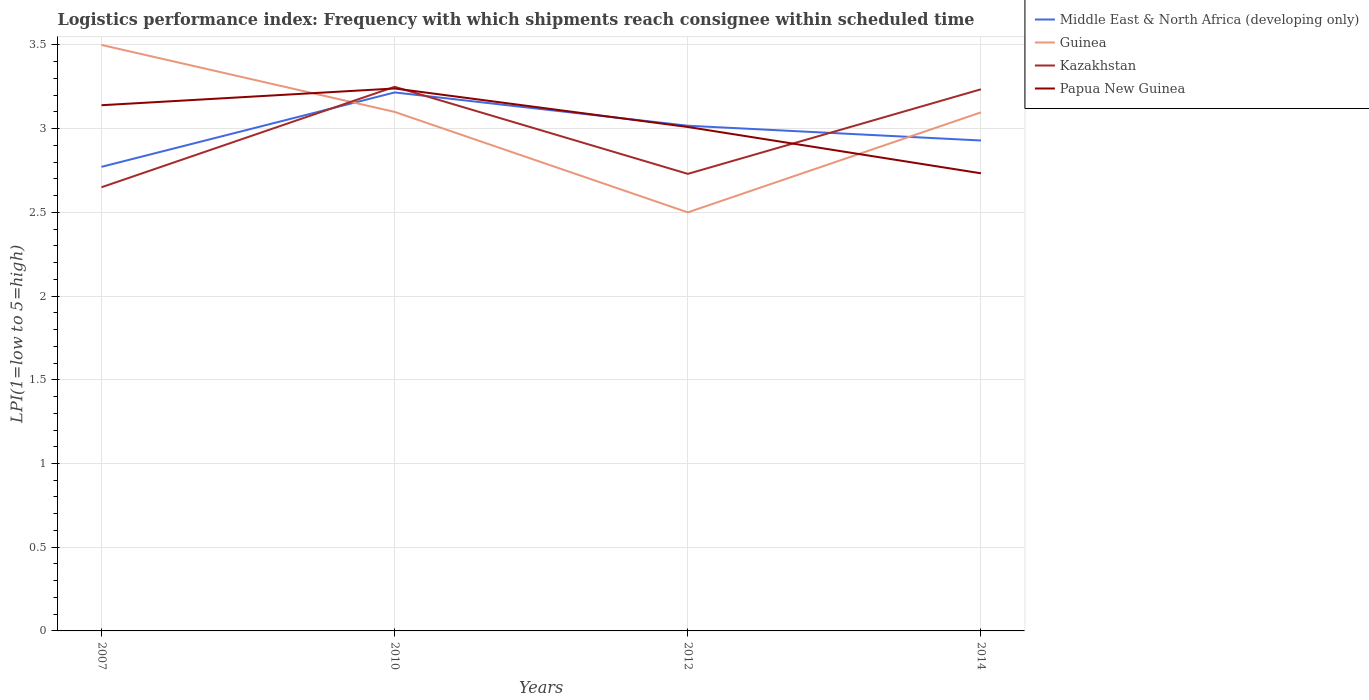How many different coloured lines are there?
Keep it short and to the point. 4. Across all years, what is the maximum logistics performance index in Papua New Guinea?
Your response must be concise. 2.73. In which year was the logistics performance index in Middle East & North Africa (developing only) maximum?
Your answer should be very brief. 2007. What is the total logistics performance index in Kazakhstan in the graph?
Provide a succinct answer. 0.52. What is the difference between the highest and the second highest logistics performance index in Papua New Guinea?
Ensure brevity in your answer.  0.51. What is the difference between the highest and the lowest logistics performance index in Middle East & North Africa (developing only)?
Give a very brief answer. 2. Is the logistics performance index in Middle East & North Africa (developing only) strictly greater than the logistics performance index in Papua New Guinea over the years?
Your answer should be very brief. No. How many years are there in the graph?
Ensure brevity in your answer.  4. What is the difference between two consecutive major ticks on the Y-axis?
Offer a terse response. 0.5. Where does the legend appear in the graph?
Your response must be concise. Top right. How are the legend labels stacked?
Your answer should be compact. Vertical. What is the title of the graph?
Make the answer very short. Logistics performance index: Frequency with which shipments reach consignee within scheduled time. What is the label or title of the X-axis?
Give a very brief answer. Years. What is the label or title of the Y-axis?
Offer a very short reply. LPI(1=low to 5=high). What is the LPI(1=low to 5=high) of Middle East & North Africa (developing only) in 2007?
Your answer should be compact. 2.77. What is the LPI(1=low to 5=high) of Guinea in 2007?
Keep it short and to the point. 3.5. What is the LPI(1=low to 5=high) of Kazakhstan in 2007?
Your answer should be very brief. 2.65. What is the LPI(1=low to 5=high) of Papua New Guinea in 2007?
Provide a succinct answer. 3.14. What is the LPI(1=low to 5=high) in Middle East & North Africa (developing only) in 2010?
Your answer should be compact. 3.22. What is the LPI(1=low to 5=high) in Guinea in 2010?
Give a very brief answer. 3.1. What is the LPI(1=low to 5=high) in Kazakhstan in 2010?
Your response must be concise. 3.25. What is the LPI(1=low to 5=high) of Papua New Guinea in 2010?
Your answer should be very brief. 3.24. What is the LPI(1=low to 5=high) of Middle East & North Africa (developing only) in 2012?
Offer a very short reply. 3.02. What is the LPI(1=low to 5=high) of Guinea in 2012?
Provide a short and direct response. 2.5. What is the LPI(1=low to 5=high) of Kazakhstan in 2012?
Your answer should be very brief. 2.73. What is the LPI(1=low to 5=high) in Papua New Guinea in 2012?
Your response must be concise. 3.01. What is the LPI(1=low to 5=high) in Middle East & North Africa (developing only) in 2014?
Make the answer very short. 2.93. What is the LPI(1=low to 5=high) in Guinea in 2014?
Ensure brevity in your answer.  3.1. What is the LPI(1=low to 5=high) in Kazakhstan in 2014?
Your response must be concise. 3.24. What is the LPI(1=low to 5=high) in Papua New Guinea in 2014?
Offer a terse response. 2.73. Across all years, what is the maximum LPI(1=low to 5=high) in Middle East & North Africa (developing only)?
Provide a short and direct response. 3.22. Across all years, what is the maximum LPI(1=low to 5=high) in Kazakhstan?
Your answer should be compact. 3.25. Across all years, what is the maximum LPI(1=low to 5=high) in Papua New Guinea?
Your answer should be compact. 3.24. Across all years, what is the minimum LPI(1=low to 5=high) in Middle East & North Africa (developing only)?
Your response must be concise. 2.77. Across all years, what is the minimum LPI(1=low to 5=high) in Kazakhstan?
Provide a short and direct response. 2.65. Across all years, what is the minimum LPI(1=low to 5=high) of Papua New Guinea?
Ensure brevity in your answer.  2.73. What is the total LPI(1=low to 5=high) of Middle East & North Africa (developing only) in the graph?
Ensure brevity in your answer.  11.94. What is the total LPI(1=low to 5=high) in Guinea in the graph?
Your answer should be compact. 12.2. What is the total LPI(1=low to 5=high) of Kazakhstan in the graph?
Your response must be concise. 11.87. What is the total LPI(1=low to 5=high) in Papua New Guinea in the graph?
Offer a very short reply. 12.12. What is the difference between the LPI(1=low to 5=high) of Middle East & North Africa (developing only) in 2007 and that in 2010?
Keep it short and to the point. -0.44. What is the difference between the LPI(1=low to 5=high) of Middle East & North Africa (developing only) in 2007 and that in 2012?
Your answer should be very brief. -0.25. What is the difference between the LPI(1=low to 5=high) of Guinea in 2007 and that in 2012?
Offer a terse response. 1. What is the difference between the LPI(1=low to 5=high) in Kazakhstan in 2007 and that in 2012?
Your answer should be compact. -0.08. What is the difference between the LPI(1=low to 5=high) of Papua New Guinea in 2007 and that in 2012?
Offer a very short reply. 0.13. What is the difference between the LPI(1=low to 5=high) of Middle East & North Africa (developing only) in 2007 and that in 2014?
Your answer should be compact. -0.16. What is the difference between the LPI(1=low to 5=high) of Guinea in 2007 and that in 2014?
Your answer should be very brief. 0.4. What is the difference between the LPI(1=low to 5=high) in Kazakhstan in 2007 and that in 2014?
Offer a terse response. -0.59. What is the difference between the LPI(1=low to 5=high) of Papua New Guinea in 2007 and that in 2014?
Offer a terse response. 0.41. What is the difference between the LPI(1=low to 5=high) of Middle East & North Africa (developing only) in 2010 and that in 2012?
Offer a very short reply. 0.2. What is the difference between the LPI(1=low to 5=high) in Guinea in 2010 and that in 2012?
Keep it short and to the point. 0.6. What is the difference between the LPI(1=low to 5=high) in Kazakhstan in 2010 and that in 2012?
Your answer should be compact. 0.52. What is the difference between the LPI(1=low to 5=high) in Papua New Guinea in 2010 and that in 2012?
Make the answer very short. 0.23. What is the difference between the LPI(1=low to 5=high) of Middle East & North Africa (developing only) in 2010 and that in 2014?
Ensure brevity in your answer.  0.29. What is the difference between the LPI(1=low to 5=high) of Guinea in 2010 and that in 2014?
Give a very brief answer. 0. What is the difference between the LPI(1=low to 5=high) of Kazakhstan in 2010 and that in 2014?
Your response must be concise. 0.01. What is the difference between the LPI(1=low to 5=high) in Papua New Guinea in 2010 and that in 2014?
Your answer should be compact. 0.51. What is the difference between the LPI(1=low to 5=high) in Middle East & North Africa (developing only) in 2012 and that in 2014?
Your answer should be very brief. 0.09. What is the difference between the LPI(1=low to 5=high) of Guinea in 2012 and that in 2014?
Offer a terse response. -0.6. What is the difference between the LPI(1=low to 5=high) of Kazakhstan in 2012 and that in 2014?
Keep it short and to the point. -0.51. What is the difference between the LPI(1=low to 5=high) in Papua New Guinea in 2012 and that in 2014?
Make the answer very short. 0.28. What is the difference between the LPI(1=low to 5=high) of Middle East & North Africa (developing only) in 2007 and the LPI(1=low to 5=high) of Guinea in 2010?
Provide a short and direct response. -0.33. What is the difference between the LPI(1=low to 5=high) in Middle East & North Africa (developing only) in 2007 and the LPI(1=low to 5=high) in Kazakhstan in 2010?
Offer a terse response. -0.48. What is the difference between the LPI(1=low to 5=high) of Middle East & North Africa (developing only) in 2007 and the LPI(1=low to 5=high) of Papua New Guinea in 2010?
Keep it short and to the point. -0.47. What is the difference between the LPI(1=low to 5=high) in Guinea in 2007 and the LPI(1=low to 5=high) in Kazakhstan in 2010?
Provide a succinct answer. 0.25. What is the difference between the LPI(1=low to 5=high) in Guinea in 2007 and the LPI(1=low to 5=high) in Papua New Guinea in 2010?
Ensure brevity in your answer.  0.26. What is the difference between the LPI(1=low to 5=high) in Kazakhstan in 2007 and the LPI(1=low to 5=high) in Papua New Guinea in 2010?
Offer a very short reply. -0.59. What is the difference between the LPI(1=low to 5=high) in Middle East & North Africa (developing only) in 2007 and the LPI(1=low to 5=high) in Guinea in 2012?
Keep it short and to the point. 0.27. What is the difference between the LPI(1=low to 5=high) of Middle East & North Africa (developing only) in 2007 and the LPI(1=low to 5=high) of Kazakhstan in 2012?
Provide a short and direct response. 0.04. What is the difference between the LPI(1=low to 5=high) of Middle East & North Africa (developing only) in 2007 and the LPI(1=low to 5=high) of Papua New Guinea in 2012?
Provide a short and direct response. -0.24. What is the difference between the LPI(1=low to 5=high) in Guinea in 2007 and the LPI(1=low to 5=high) in Kazakhstan in 2012?
Provide a succinct answer. 0.77. What is the difference between the LPI(1=low to 5=high) of Guinea in 2007 and the LPI(1=low to 5=high) of Papua New Guinea in 2012?
Make the answer very short. 0.49. What is the difference between the LPI(1=low to 5=high) in Kazakhstan in 2007 and the LPI(1=low to 5=high) in Papua New Guinea in 2012?
Keep it short and to the point. -0.36. What is the difference between the LPI(1=low to 5=high) of Middle East & North Africa (developing only) in 2007 and the LPI(1=low to 5=high) of Guinea in 2014?
Your answer should be very brief. -0.33. What is the difference between the LPI(1=low to 5=high) of Middle East & North Africa (developing only) in 2007 and the LPI(1=low to 5=high) of Kazakhstan in 2014?
Your answer should be very brief. -0.46. What is the difference between the LPI(1=low to 5=high) of Middle East & North Africa (developing only) in 2007 and the LPI(1=low to 5=high) of Papua New Guinea in 2014?
Provide a succinct answer. 0.04. What is the difference between the LPI(1=low to 5=high) of Guinea in 2007 and the LPI(1=low to 5=high) of Kazakhstan in 2014?
Make the answer very short. 0.26. What is the difference between the LPI(1=low to 5=high) in Guinea in 2007 and the LPI(1=low to 5=high) in Papua New Guinea in 2014?
Give a very brief answer. 0.77. What is the difference between the LPI(1=low to 5=high) in Kazakhstan in 2007 and the LPI(1=low to 5=high) in Papua New Guinea in 2014?
Your response must be concise. -0.08. What is the difference between the LPI(1=low to 5=high) in Middle East & North Africa (developing only) in 2010 and the LPI(1=low to 5=high) in Guinea in 2012?
Your response must be concise. 0.72. What is the difference between the LPI(1=low to 5=high) of Middle East & North Africa (developing only) in 2010 and the LPI(1=low to 5=high) of Kazakhstan in 2012?
Give a very brief answer. 0.49. What is the difference between the LPI(1=low to 5=high) in Middle East & North Africa (developing only) in 2010 and the LPI(1=low to 5=high) in Papua New Guinea in 2012?
Your response must be concise. 0.21. What is the difference between the LPI(1=low to 5=high) of Guinea in 2010 and the LPI(1=low to 5=high) of Kazakhstan in 2012?
Give a very brief answer. 0.37. What is the difference between the LPI(1=low to 5=high) in Guinea in 2010 and the LPI(1=low to 5=high) in Papua New Guinea in 2012?
Your response must be concise. 0.09. What is the difference between the LPI(1=low to 5=high) in Kazakhstan in 2010 and the LPI(1=low to 5=high) in Papua New Guinea in 2012?
Your response must be concise. 0.24. What is the difference between the LPI(1=low to 5=high) of Middle East & North Africa (developing only) in 2010 and the LPI(1=low to 5=high) of Guinea in 2014?
Your answer should be compact. 0.12. What is the difference between the LPI(1=low to 5=high) of Middle East & North Africa (developing only) in 2010 and the LPI(1=low to 5=high) of Kazakhstan in 2014?
Offer a terse response. -0.02. What is the difference between the LPI(1=low to 5=high) in Middle East & North Africa (developing only) in 2010 and the LPI(1=low to 5=high) in Papua New Guinea in 2014?
Your answer should be very brief. 0.48. What is the difference between the LPI(1=low to 5=high) in Guinea in 2010 and the LPI(1=low to 5=high) in Kazakhstan in 2014?
Offer a terse response. -0.14. What is the difference between the LPI(1=low to 5=high) in Guinea in 2010 and the LPI(1=low to 5=high) in Papua New Guinea in 2014?
Make the answer very short. 0.37. What is the difference between the LPI(1=low to 5=high) in Kazakhstan in 2010 and the LPI(1=low to 5=high) in Papua New Guinea in 2014?
Ensure brevity in your answer.  0.52. What is the difference between the LPI(1=low to 5=high) of Middle East & North Africa (developing only) in 2012 and the LPI(1=low to 5=high) of Guinea in 2014?
Keep it short and to the point. -0.08. What is the difference between the LPI(1=low to 5=high) of Middle East & North Africa (developing only) in 2012 and the LPI(1=low to 5=high) of Kazakhstan in 2014?
Make the answer very short. -0.22. What is the difference between the LPI(1=low to 5=high) of Middle East & North Africa (developing only) in 2012 and the LPI(1=low to 5=high) of Papua New Guinea in 2014?
Provide a succinct answer. 0.28. What is the difference between the LPI(1=low to 5=high) of Guinea in 2012 and the LPI(1=low to 5=high) of Kazakhstan in 2014?
Provide a short and direct response. -0.74. What is the difference between the LPI(1=low to 5=high) in Guinea in 2012 and the LPI(1=low to 5=high) in Papua New Guinea in 2014?
Provide a succinct answer. -0.23. What is the difference between the LPI(1=low to 5=high) in Kazakhstan in 2012 and the LPI(1=low to 5=high) in Papua New Guinea in 2014?
Provide a succinct answer. -0. What is the average LPI(1=low to 5=high) in Middle East & North Africa (developing only) per year?
Keep it short and to the point. 2.98. What is the average LPI(1=low to 5=high) in Guinea per year?
Your answer should be very brief. 3.05. What is the average LPI(1=low to 5=high) in Kazakhstan per year?
Provide a short and direct response. 2.97. What is the average LPI(1=low to 5=high) of Papua New Guinea per year?
Your answer should be very brief. 3.03. In the year 2007, what is the difference between the LPI(1=low to 5=high) of Middle East & North Africa (developing only) and LPI(1=low to 5=high) of Guinea?
Keep it short and to the point. -0.73. In the year 2007, what is the difference between the LPI(1=low to 5=high) in Middle East & North Africa (developing only) and LPI(1=low to 5=high) in Kazakhstan?
Provide a short and direct response. 0.12. In the year 2007, what is the difference between the LPI(1=low to 5=high) of Middle East & North Africa (developing only) and LPI(1=low to 5=high) of Papua New Guinea?
Offer a very short reply. -0.37. In the year 2007, what is the difference between the LPI(1=low to 5=high) of Guinea and LPI(1=low to 5=high) of Papua New Guinea?
Make the answer very short. 0.36. In the year 2007, what is the difference between the LPI(1=low to 5=high) in Kazakhstan and LPI(1=low to 5=high) in Papua New Guinea?
Give a very brief answer. -0.49. In the year 2010, what is the difference between the LPI(1=low to 5=high) in Middle East & North Africa (developing only) and LPI(1=low to 5=high) in Guinea?
Make the answer very short. 0.12. In the year 2010, what is the difference between the LPI(1=low to 5=high) in Middle East & North Africa (developing only) and LPI(1=low to 5=high) in Kazakhstan?
Your answer should be compact. -0.03. In the year 2010, what is the difference between the LPI(1=low to 5=high) in Middle East & North Africa (developing only) and LPI(1=low to 5=high) in Papua New Guinea?
Give a very brief answer. -0.02. In the year 2010, what is the difference between the LPI(1=low to 5=high) of Guinea and LPI(1=low to 5=high) of Papua New Guinea?
Give a very brief answer. -0.14. In the year 2010, what is the difference between the LPI(1=low to 5=high) of Kazakhstan and LPI(1=low to 5=high) of Papua New Guinea?
Make the answer very short. 0.01. In the year 2012, what is the difference between the LPI(1=low to 5=high) in Middle East & North Africa (developing only) and LPI(1=low to 5=high) in Guinea?
Your answer should be very brief. 0.52. In the year 2012, what is the difference between the LPI(1=low to 5=high) of Middle East & North Africa (developing only) and LPI(1=low to 5=high) of Kazakhstan?
Provide a short and direct response. 0.29. In the year 2012, what is the difference between the LPI(1=low to 5=high) in Middle East & North Africa (developing only) and LPI(1=low to 5=high) in Papua New Guinea?
Offer a terse response. 0.01. In the year 2012, what is the difference between the LPI(1=low to 5=high) of Guinea and LPI(1=low to 5=high) of Kazakhstan?
Offer a very short reply. -0.23. In the year 2012, what is the difference between the LPI(1=low to 5=high) of Guinea and LPI(1=low to 5=high) of Papua New Guinea?
Ensure brevity in your answer.  -0.51. In the year 2012, what is the difference between the LPI(1=low to 5=high) in Kazakhstan and LPI(1=low to 5=high) in Papua New Guinea?
Offer a very short reply. -0.28. In the year 2014, what is the difference between the LPI(1=low to 5=high) of Middle East & North Africa (developing only) and LPI(1=low to 5=high) of Guinea?
Make the answer very short. -0.17. In the year 2014, what is the difference between the LPI(1=low to 5=high) of Middle East & North Africa (developing only) and LPI(1=low to 5=high) of Kazakhstan?
Provide a succinct answer. -0.31. In the year 2014, what is the difference between the LPI(1=low to 5=high) of Middle East & North Africa (developing only) and LPI(1=low to 5=high) of Papua New Guinea?
Your answer should be very brief. 0.2. In the year 2014, what is the difference between the LPI(1=low to 5=high) of Guinea and LPI(1=low to 5=high) of Kazakhstan?
Offer a very short reply. -0.14. In the year 2014, what is the difference between the LPI(1=low to 5=high) of Guinea and LPI(1=low to 5=high) of Papua New Guinea?
Your response must be concise. 0.36. In the year 2014, what is the difference between the LPI(1=low to 5=high) in Kazakhstan and LPI(1=low to 5=high) in Papua New Guinea?
Make the answer very short. 0.5. What is the ratio of the LPI(1=low to 5=high) of Middle East & North Africa (developing only) in 2007 to that in 2010?
Ensure brevity in your answer.  0.86. What is the ratio of the LPI(1=low to 5=high) of Guinea in 2007 to that in 2010?
Give a very brief answer. 1.13. What is the ratio of the LPI(1=low to 5=high) in Kazakhstan in 2007 to that in 2010?
Your answer should be compact. 0.82. What is the ratio of the LPI(1=low to 5=high) in Papua New Guinea in 2007 to that in 2010?
Give a very brief answer. 0.97. What is the ratio of the LPI(1=low to 5=high) in Middle East & North Africa (developing only) in 2007 to that in 2012?
Ensure brevity in your answer.  0.92. What is the ratio of the LPI(1=low to 5=high) in Guinea in 2007 to that in 2012?
Give a very brief answer. 1.4. What is the ratio of the LPI(1=low to 5=high) in Kazakhstan in 2007 to that in 2012?
Provide a succinct answer. 0.97. What is the ratio of the LPI(1=low to 5=high) of Papua New Guinea in 2007 to that in 2012?
Ensure brevity in your answer.  1.04. What is the ratio of the LPI(1=low to 5=high) in Middle East & North Africa (developing only) in 2007 to that in 2014?
Offer a very short reply. 0.95. What is the ratio of the LPI(1=low to 5=high) in Guinea in 2007 to that in 2014?
Provide a succinct answer. 1.13. What is the ratio of the LPI(1=low to 5=high) of Kazakhstan in 2007 to that in 2014?
Offer a very short reply. 0.82. What is the ratio of the LPI(1=low to 5=high) of Papua New Guinea in 2007 to that in 2014?
Your response must be concise. 1.15. What is the ratio of the LPI(1=low to 5=high) of Middle East & North Africa (developing only) in 2010 to that in 2012?
Provide a short and direct response. 1.07. What is the ratio of the LPI(1=low to 5=high) of Guinea in 2010 to that in 2012?
Make the answer very short. 1.24. What is the ratio of the LPI(1=low to 5=high) of Kazakhstan in 2010 to that in 2012?
Provide a short and direct response. 1.19. What is the ratio of the LPI(1=low to 5=high) of Papua New Guinea in 2010 to that in 2012?
Provide a succinct answer. 1.08. What is the ratio of the LPI(1=low to 5=high) in Middle East & North Africa (developing only) in 2010 to that in 2014?
Keep it short and to the point. 1.1. What is the ratio of the LPI(1=low to 5=high) in Guinea in 2010 to that in 2014?
Your answer should be compact. 1. What is the ratio of the LPI(1=low to 5=high) in Papua New Guinea in 2010 to that in 2014?
Offer a very short reply. 1.19. What is the ratio of the LPI(1=low to 5=high) in Middle East & North Africa (developing only) in 2012 to that in 2014?
Give a very brief answer. 1.03. What is the ratio of the LPI(1=low to 5=high) of Guinea in 2012 to that in 2014?
Ensure brevity in your answer.  0.81. What is the ratio of the LPI(1=low to 5=high) of Kazakhstan in 2012 to that in 2014?
Your answer should be compact. 0.84. What is the ratio of the LPI(1=low to 5=high) of Papua New Guinea in 2012 to that in 2014?
Make the answer very short. 1.1. What is the difference between the highest and the second highest LPI(1=low to 5=high) in Middle East & North Africa (developing only)?
Provide a succinct answer. 0.2. What is the difference between the highest and the second highest LPI(1=low to 5=high) of Guinea?
Offer a very short reply. 0.4. What is the difference between the highest and the second highest LPI(1=low to 5=high) in Kazakhstan?
Give a very brief answer. 0.01. What is the difference between the highest and the second highest LPI(1=low to 5=high) in Papua New Guinea?
Offer a terse response. 0.1. What is the difference between the highest and the lowest LPI(1=low to 5=high) of Middle East & North Africa (developing only)?
Offer a terse response. 0.44. What is the difference between the highest and the lowest LPI(1=low to 5=high) of Kazakhstan?
Your answer should be very brief. 0.6. What is the difference between the highest and the lowest LPI(1=low to 5=high) of Papua New Guinea?
Your answer should be very brief. 0.51. 